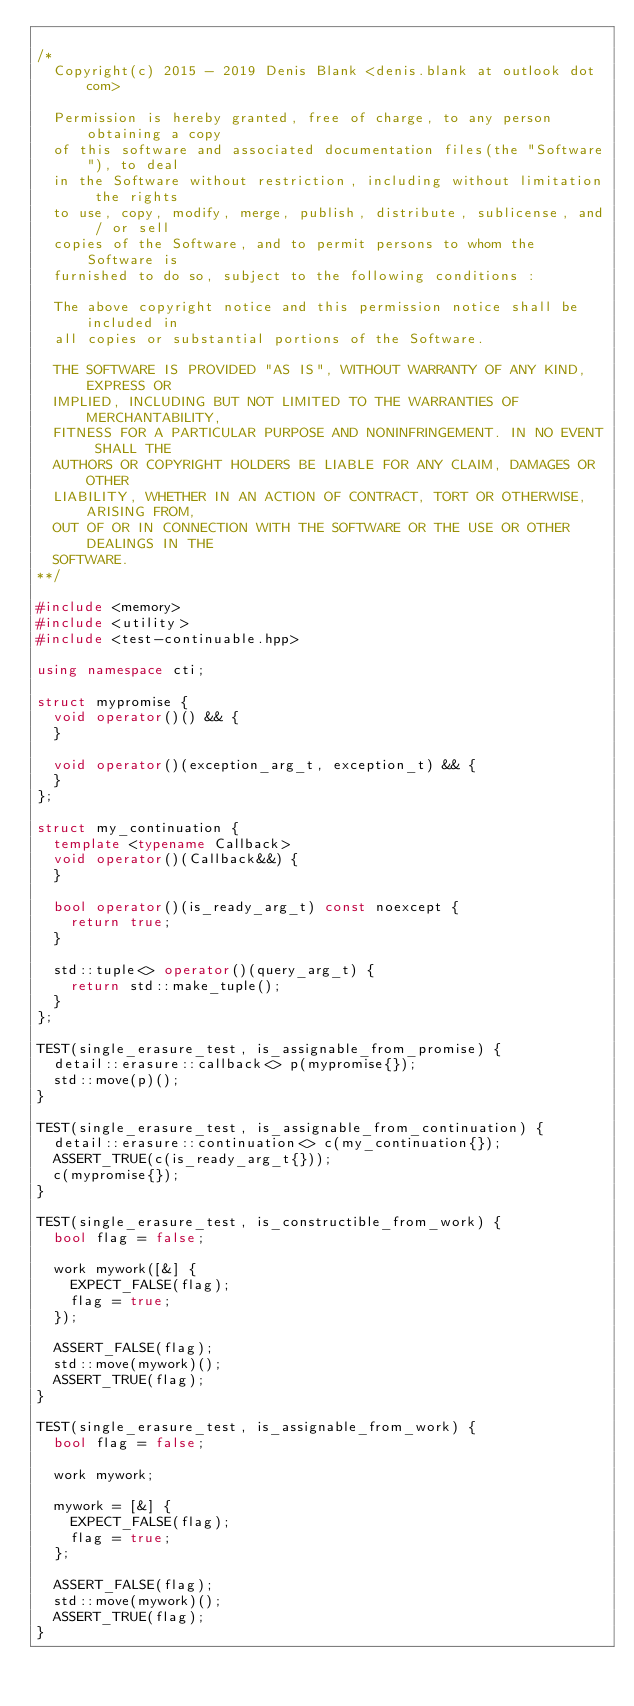Convert code to text. <code><loc_0><loc_0><loc_500><loc_500><_C++_>
/*
  Copyright(c) 2015 - 2019 Denis Blank <denis.blank at outlook dot com>

  Permission is hereby granted, free of charge, to any person obtaining a copy
  of this software and associated documentation files(the "Software"), to deal
  in the Software without restriction, including without limitation the rights
  to use, copy, modify, merge, publish, distribute, sublicense, and / or sell
  copies of the Software, and to permit persons to whom the Software is
  furnished to do so, subject to the following conditions :

  The above copyright notice and this permission notice shall be included in
  all copies or substantial portions of the Software.

  THE SOFTWARE IS PROVIDED "AS IS", WITHOUT WARRANTY OF ANY KIND, EXPRESS OR
  IMPLIED, INCLUDING BUT NOT LIMITED TO THE WARRANTIES OF MERCHANTABILITY,
  FITNESS FOR A PARTICULAR PURPOSE AND NONINFRINGEMENT. IN NO EVENT SHALL THE
  AUTHORS OR COPYRIGHT HOLDERS BE LIABLE FOR ANY CLAIM, DAMAGES OR OTHER
  LIABILITY, WHETHER IN AN ACTION OF CONTRACT, TORT OR OTHERWISE, ARISING FROM,
  OUT OF OR IN CONNECTION WITH THE SOFTWARE OR THE USE OR OTHER DEALINGS IN THE
  SOFTWARE.
**/

#include <memory>
#include <utility>
#include <test-continuable.hpp>

using namespace cti;

struct mypromise {
  void operator()() && {
  }

  void operator()(exception_arg_t, exception_t) && {
  }
};

struct my_continuation {
  template <typename Callback>
  void operator()(Callback&&) {
  }

  bool operator()(is_ready_arg_t) const noexcept {
    return true;
  }

  std::tuple<> operator()(query_arg_t) {
    return std::make_tuple();
  }
};

TEST(single_erasure_test, is_assignable_from_promise) {
  detail::erasure::callback<> p(mypromise{});
  std::move(p)();
}

TEST(single_erasure_test, is_assignable_from_continuation) {
  detail::erasure::continuation<> c(my_continuation{});
  ASSERT_TRUE(c(is_ready_arg_t{}));
  c(mypromise{});
}

TEST(single_erasure_test, is_constructible_from_work) {
  bool flag = false;

  work mywork([&] {
    EXPECT_FALSE(flag);
    flag = true;
  });

  ASSERT_FALSE(flag);
  std::move(mywork)();
  ASSERT_TRUE(flag);
}

TEST(single_erasure_test, is_assignable_from_work) {
  bool flag = false;

  work mywork;

  mywork = [&] {
    EXPECT_FALSE(flag);
    flag = true;
  };

  ASSERT_FALSE(flag);
  std::move(mywork)();
  ASSERT_TRUE(flag);
}
</code> 